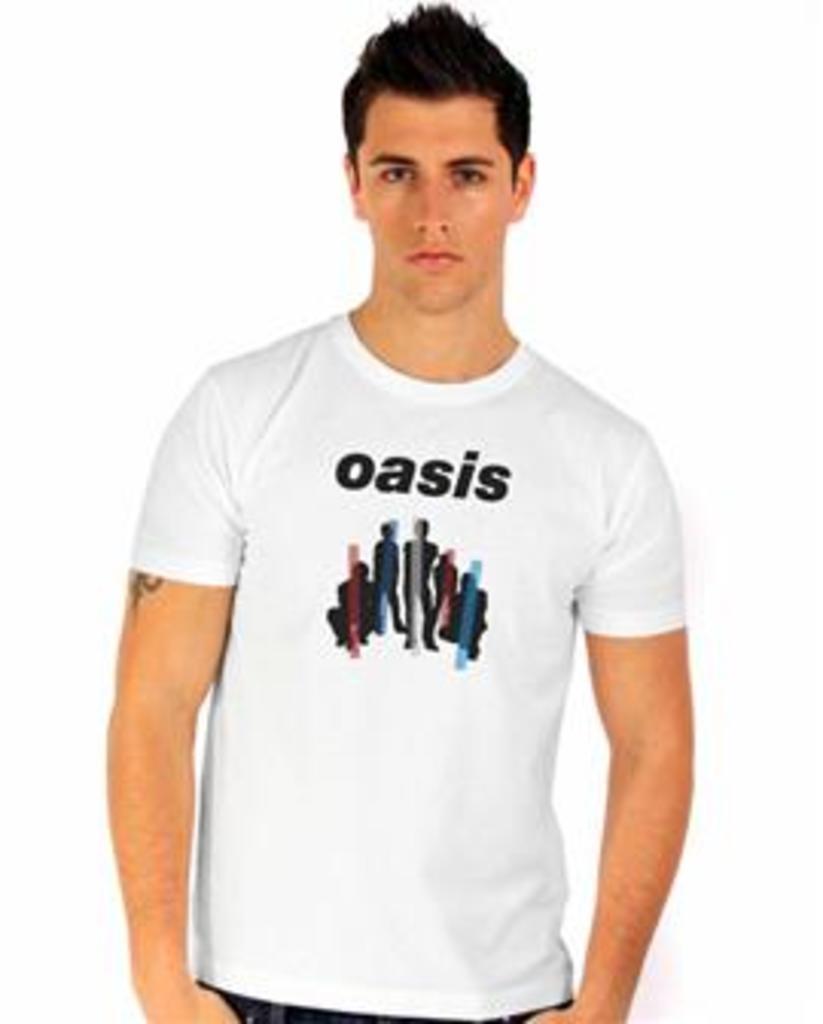How would you summarize this image in a sentence or two? In this image we can see a person. A person is wearing a white color T-shirt and some text and persons printed on it. There is a white background in the image. 